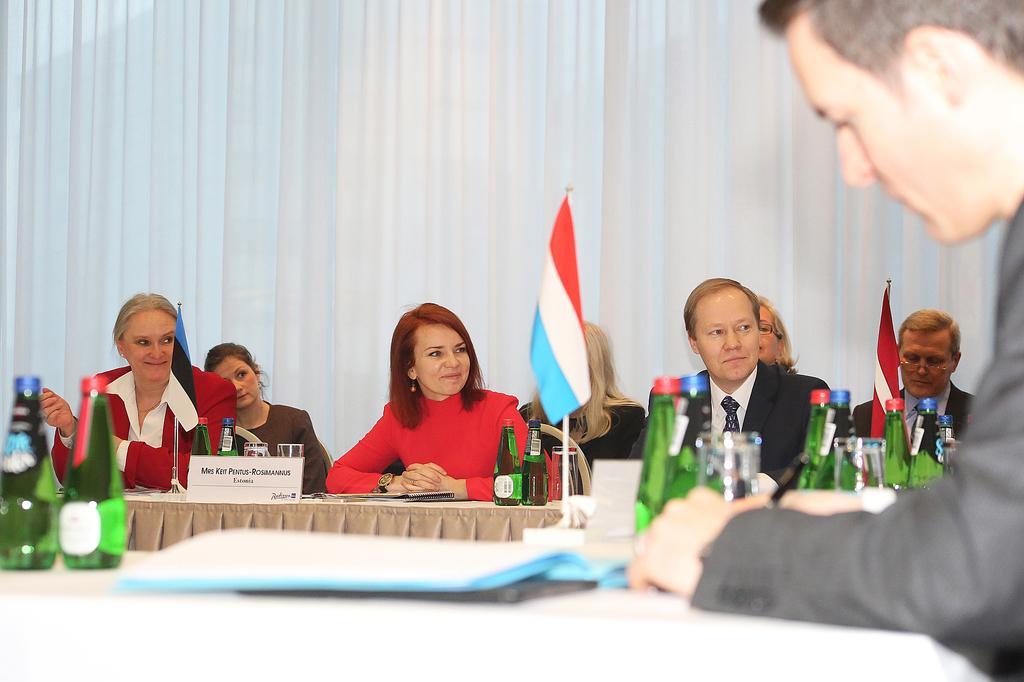Please provide a concise description of this image. This image is clicked, inside the room. There are many people sitting in this image. To the right, the man wearing black suit is sitting and writing. To the left, there is a woman sitting and wearing a red suit. In front of her there is a table, on which there are bottles, name plates and glasses along with a flag. In the background, there is a white cloth. 